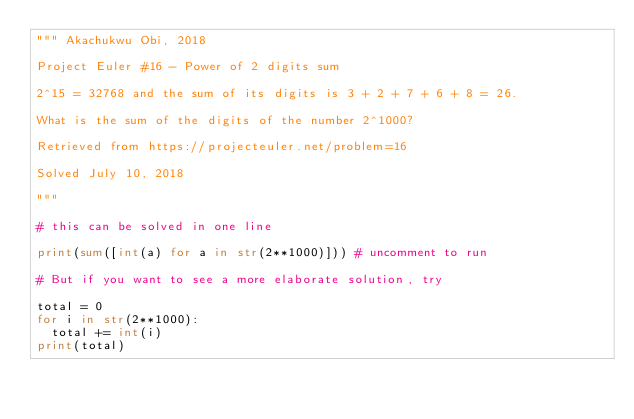<code> <loc_0><loc_0><loc_500><loc_500><_Python_>""" Akachukwu Obi, 2018

Project Euler #16 - Power of 2 digits sum

2^15 = 32768 and the sum of its digits is 3 + 2 + 7 + 6 + 8 = 26.

What is the sum of the digits of the number 2^1000?

Retrieved from https://projecteuler.net/problem=16

Solved July 10, 2018

"""

# this can be solved in one line

print(sum([int(a) for a in str(2**1000)])) # uncomment to run

# But if you want to see a more elaborate solution, try

total = 0
for i in str(2**1000):
	total += int(i)
print(total)

</code> 